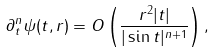<formula> <loc_0><loc_0><loc_500><loc_500>\partial _ { t } ^ { n } \psi ( t , r ) = O \left ( \frac { r ^ { 2 } | t | } { | \sin t | ^ { n + 1 } } \right ) ,</formula> 